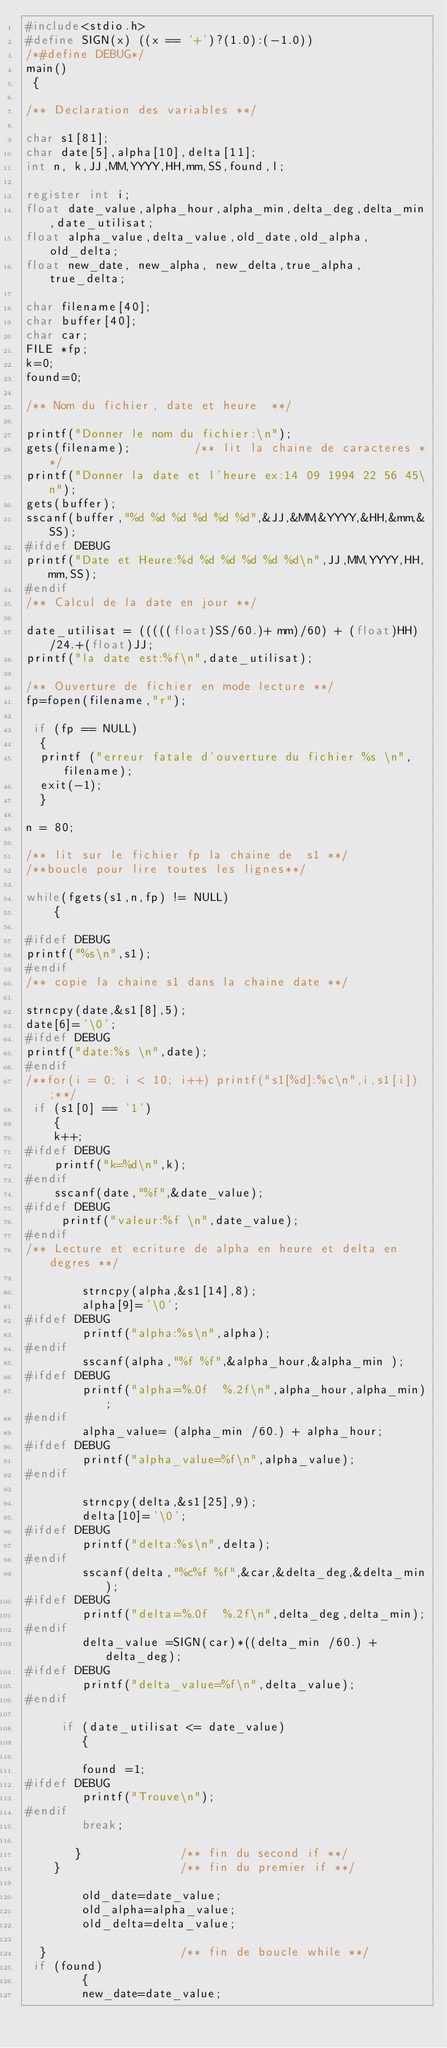<code> <loc_0><loc_0><loc_500><loc_500><_C_>#include<stdio.h>
#define SIGN(x) ((x == '+')?(1.0):(-1.0)) 
/*#define DEBUG*/
main()
 {

/** Declaration des variables **/

char s1[81]; 
char date[5],alpha[10],delta[11];
int n, k,JJ,MM,YYYY,HH,mm,SS,found,l;

register int i;
float date_value,alpha_hour,alpha_min,delta_deg,delta_min,date_utilisat;
float alpha_value,delta_value,old_date,old_alpha,old_delta;
float new_date, new_alpha, new_delta,true_alpha,true_delta;

char filename[40];
char buffer[40];
char car;
FILE *fp;
k=0;
found=0;

/** Nom du fichier, date et heure  **/

printf("Donner le nom du fichier:\n");
gets(filename);         /** lit la chaine de caracteres **/         
printf("Donner la date et l'heure ex:14 09 1994 22 56 45\n");
gets(buffer);  
sscanf(buffer,"%d %d %d %d %d %d",&JJ,&MM,&YYYY,&HH,&mm,&SS);
#ifdef DEBUG
printf("Date et Heure:%d %d %d %d %d %d\n",JJ,MM,YYYY,HH,mm,SS);
#endif
/** Calcul de la date en jour **/

date_utilisat = (((((float)SS/60.)+ mm)/60) + (float)HH)/24.+(float)JJ;
printf("la date est:%f\n",date_utilisat);

/** Ouverture de fichier en mode lecture **/
fp=fopen(filename,"r"); 
                        
 if (fp == NULL)
  {
  printf ("erreur fatale d'ouverture du fichier %s \n",filename);
  exit(-1);
  }  

n = 80;

/** lit sur le fichier fp la chaine de  s1 **/      
/**boucle pour lire toutes les lignes**/

while(fgets(s1,n,fp) != NULL)  
    {                        
 
#ifdef DEBUG
printf("%s\n",s1);
#endif
/** copie la chaine s1 dans la chaine date **/

strncpy(date,&s1[8],5);   
date[6]='\0';
#ifdef DEBUG
printf("date:%s \n",date);
#endif
/**for(i = 0; i < 10; i++) printf("s1[%d]:%c\n",i,s1[i]);**/
 if (s1[0] == '1')
    {
    k++;
#ifdef DEBUG 
    printf("k=%d\n",k);
#endif
    sscanf(date,"%f",&date_value);
#ifdef DEBUG
     printf("valeur:%f \n",date_value);
#endif
/** Lecture et ecriture de alpha en heure et delta en degres **/

        strncpy(alpha,&s1[14],8);
        alpha[9]='\0';
#ifdef DEBUG
        printf("alpha:%s\n",alpha);
#endif
        sscanf(alpha,"%f %f",&alpha_hour,&alpha_min );
#ifdef DEBUG
        printf("alpha=%.0f  %.2f\n",alpha_hour,alpha_min); 
#endif
        alpha_value= (alpha_min /60.) + alpha_hour;
#ifdef DEBUG
        printf("alpha_value=%f\n",alpha_value);
#endif
        
        strncpy(delta,&s1[25],9);
        delta[10]='\0';
#ifdef DEBUG
        printf("delta:%s\n",delta);
#endif
        sscanf(delta,"%c%f %f",&car,&delta_deg,&delta_min);
#ifdef DEBUG
        printf("delta=%.0f  %.2f\n",delta_deg,delta_min); 
#endif
        delta_value =SIGN(car)*((delta_min /60.) + delta_deg);
#ifdef DEBUG
        printf("delta_value=%f\n",delta_value);
#endif 

     if (date_utilisat <= date_value)
        {

        found =1;
#ifdef DEBUG
        printf("Trouve\n"); 
#endif
        break;

       }              /** fin du second if **/ 
    }                 /** fin du premier if **/ 

        old_date=date_value;
        old_alpha=alpha_value;
        old_delta=delta_value;
 
  }                   /** fin de boucle while **/
 if (found)
        {
        new_date=date_value;</code> 